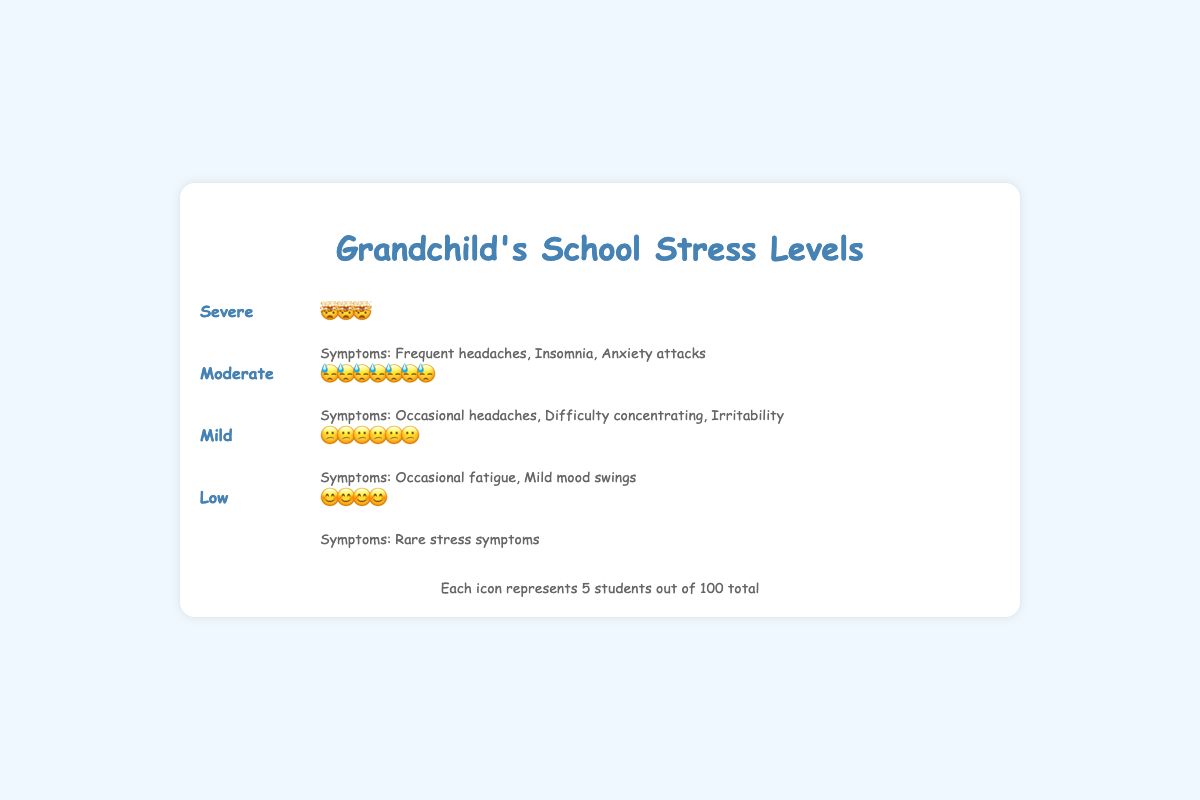What does the title of the figure indicate? The title of the figure, "Grandchild's School Stress Levels," suggests that the plot is about the stress levels experienced by students, possibly including your grandchild's school.
Answer: Grandchild's School Stress Levels How many stress levels are represented in the plot? The plot shows four stress levels, evident from the visual sections labeled as Severe, Moderate, Mild, and Low.
Answer: Four What proportion of students experience severe stress according to the plot? The Severe stress level is visually represented by three icons and the legend states that each icon represents 5 students. Thus, the proportion is 3 icons * 5 students/icon = 15 students.
Answer: 15% Which stress level has the highest proportion of students? By observing the number of icons, the Moderate stress level has the most icons, indicating it has the highest proportion of students.
Answer: Moderate What kind of symptoms are associated with the "Moderate" stress level? The symptoms for the Moderate stress level listed are "Occasional headaches," "Difficulty concentrating," and "Irritability."
Answer: Occasional headaches, Difficulty concentrating, Irritability How many students experience stress at a "Low" level in total? The Low stress level is represented by four icons, each representing 5 students. Thus, the total number of students is 4 icons * 5 students/icon = 20 students.
Answer: 20 What is the total proportion of students experiencing Moderate or higher levels of stress? Add the proportions of the Severe and Moderate stress levels: 35% (Moderate) + 15% (Severe) = 50%.
Answer: 50% Which stress level is associated with the symptom "Insomnia"? The symptom "Insomnia" is listed under the Severe stress level.
Answer: Severe Compare the total proportions of students experiencing Mild and Moderate stress levels. Which has a greater proportion and by how much? The Mild stress level has a proportion of 30%, and the Moderate stress level has a proportion of 35%. The difference is 35% - 30% = 5%.
Answer: Moderate by 5% What does each icon represent in the plot? According to the legend found at the bottom of the figure, each icon represents 5 students out of a total of 100 students.
Answer: 5 students 